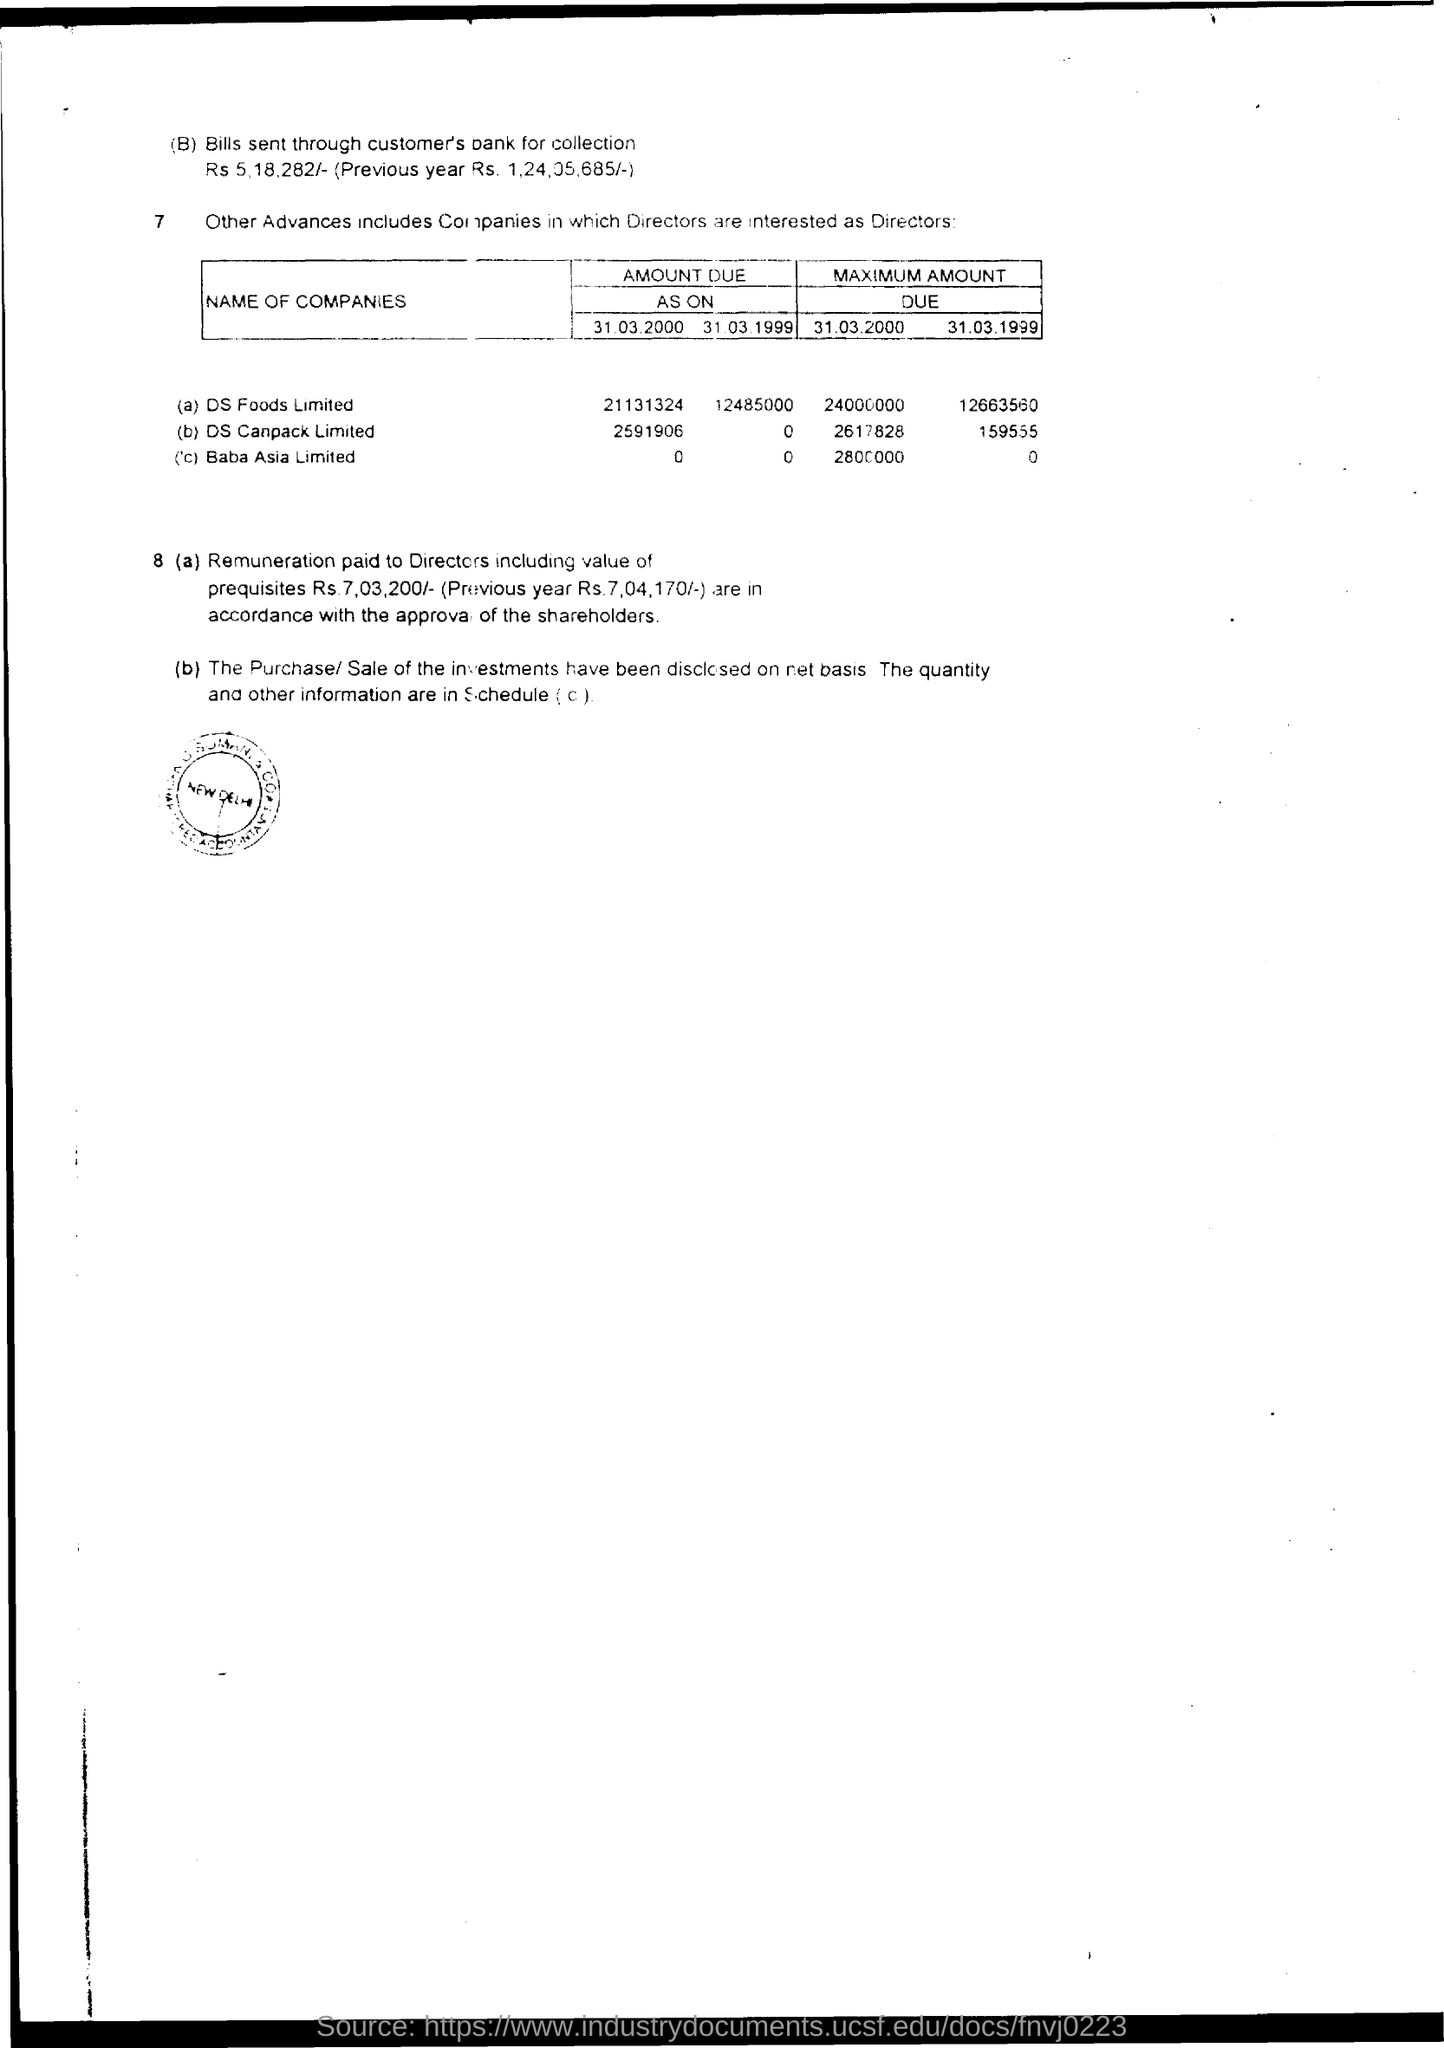What is the Maximum Amount Due on 31.03.2000 for Baba Asia Limited?
Provide a succinct answer. 2800000. What is the Maximum Amount Due on 31.03.1999 for DS Canpack Limited??
Ensure brevity in your answer.  159555. What is the remuneration paid to Directors including value of prequisites?
Give a very brief answer. Rs 7,03,200/-. What is the amount of bill sent through customer's bank for collection?
Offer a terse response. Rs 5,18,282/-. What is the Amount Due as on 31.03.1999 for DS Foods Limited?
Your response must be concise. 12485000. 